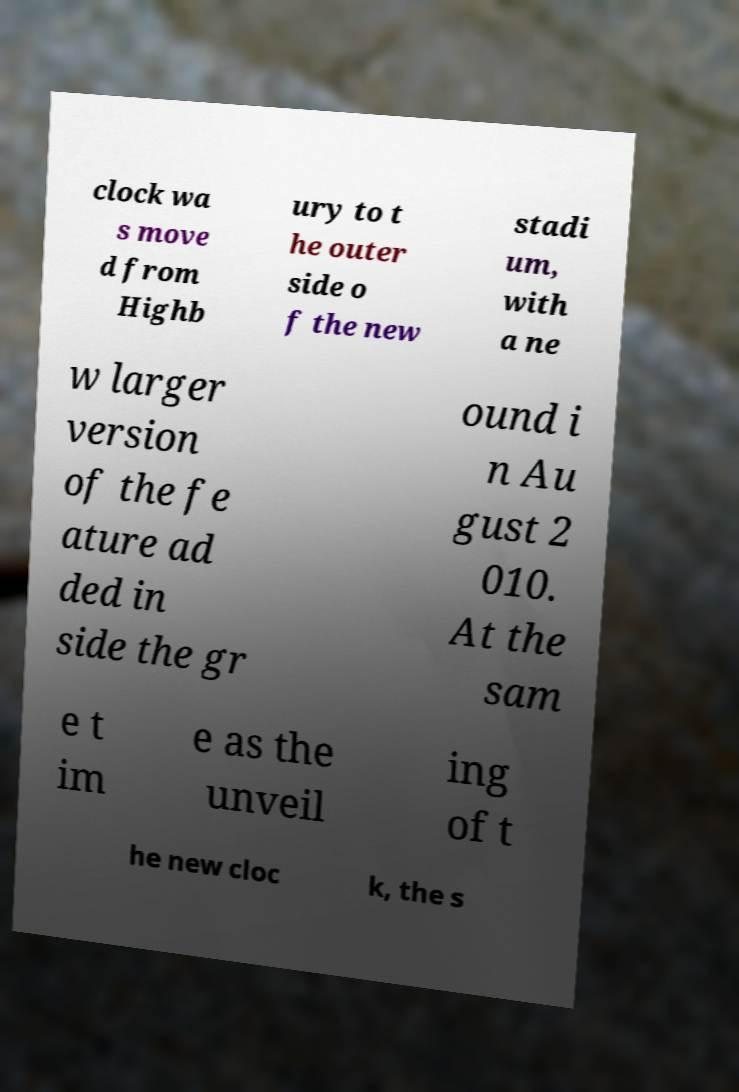Can you accurately transcribe the text from the provided image for me? clock wa s move d from Highb ury to t he outer side o f the new stadi um, with a ne w larger version of the fe ature ad ded in side the gr ound i n Au gust 2 010. At the sam e t im e as the unveil ing of t he new cloc k, the s 